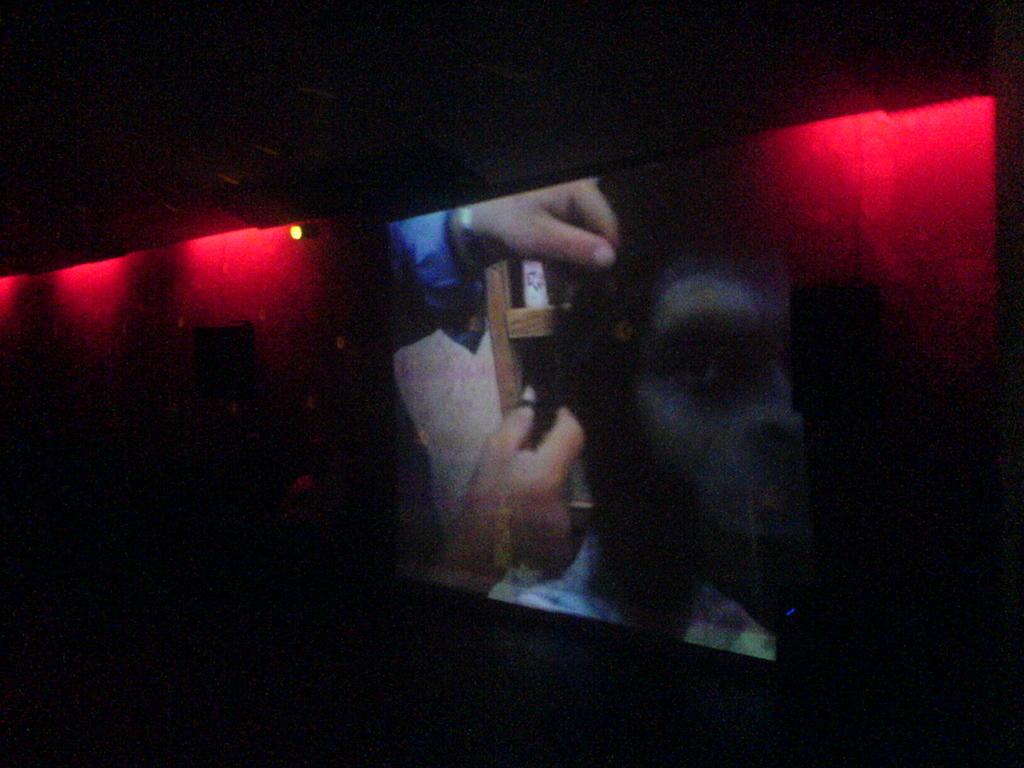What is the main object in the image? There is a screen in the image. What can be seen on the screen? A man's face is visible on the screen. What is happening near the screen? There are hands near the screen. What color light is present in the image? There is a red color light in the image. Where is the red light focused? The red light is focused on the wall. Can you see any celery in the yard in the image? There is no yard or celery present in the image. How many visitors are in the image? There is no mention of visitors in the image; it only features a screen, a man's face, hands, and a red light. 